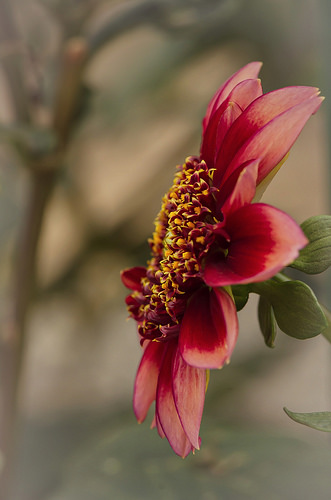<image>
Can you confirm if the petal is to the left of the leaf? Yes. From this viewpoint, the petal is positioned to the left side relative to the leaf. 